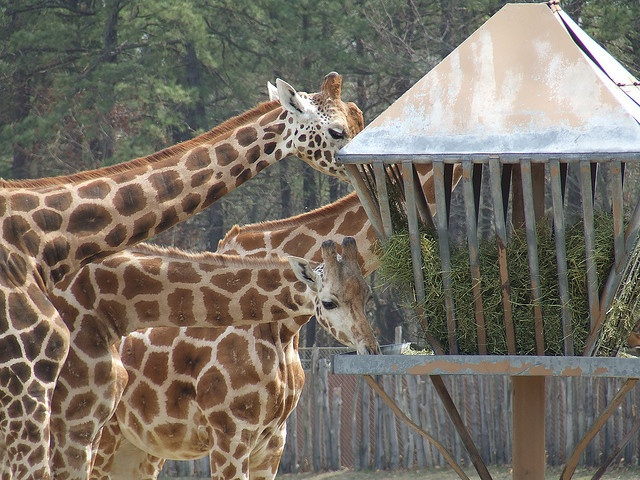Describe the objects in this image and their specific colors. I can see giraffe in gray, tan, and darkgray tones, giraffe in gray, brown, and tan tones, and giraffe in gray and maroon tones in this image. 